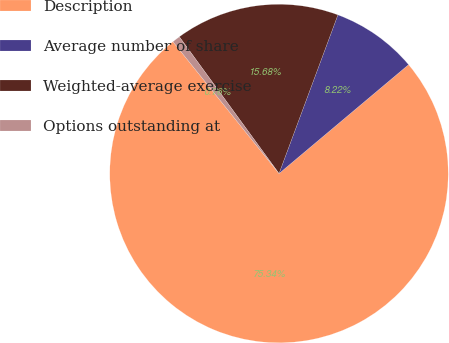<chart> <loc_0><loc_0><loc_500><loc_500><pie_chart><fcel>Description<fcel>Average number of share<fcel>Weighted-average exercise<fcel>Options outstanding at<nl><fcel>75.34%<fcel>8.22%<fcel>15.68%<fcel>0.76%<nl></chart> 